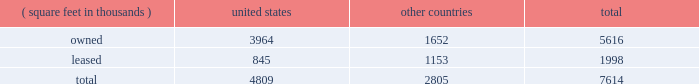Item 2 : properties information concerning applied 2019s properties is set forth below: .
Because of the interrelation of applied 2019s operations , properties within a country may be shared by the segments operating within that country .
The company 2019s headquarters offices are in santa clara , california .
Products in semiconductor systems are manufactured in santa clara , california ; austin , texas ; gloucester , massachusetts ; kalispell , montana ; rehovot , israel ; and singapore .
Remanufactured equipment products in the applied global services segment are produced primarily in austin , texas .
Products in the display and adjacent markets segment are manufactured in alzenau , germany ; and tainan , taiwan .
Other products are manufactured in treviso , italy .
Applied also owns and leases offices , plants and warehouse locations in many locations throughout the world , including in europe , japan , north america ( principally the united states ) , israel , china , india , korea , southeast asia and taiwan .
These facilities are principally used for manufacturing ; research , development and engineering ; and marketing , sales and customer support .
Applied also owns a total of approximately 269 acres of buildable land in montana , texas , california , israel and italy that could accommodate additional building space .
Applied considers the properties that it owns or leases as adequate to meet its current and future requirements .
Applied regularly assesses the size , capability and location of its global infrastructure and periodically makes adjustments based on these assessments. .
What percentage of the company's property is located in other countries and it is owned by the company? 
Computations: (1652 / 7614)
Answer: 0.21697. 